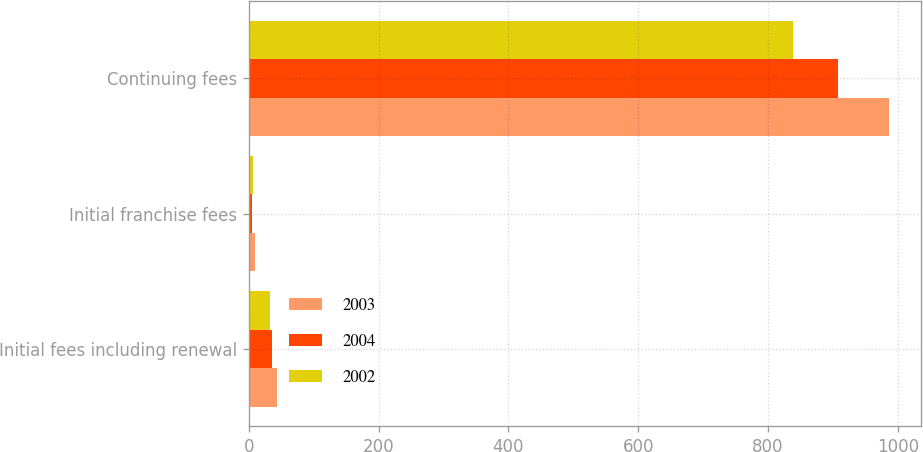Convert chart. <chart><loc_0><loc_0><loc_500><loc_500><stacked_bar_chart><ecel><fcel>Initial fees including renewal<fcel>Initial franchise fees<fcel>Continuing fees<nl><fcel>2003<fcel>43<fcel>10<fcel>986<nl><fcel>2004<fcel>36<fcel>5<fcel>908<nl><fcel>2002<fcel>33<fcel>6<fcel>839<nl></chart> 